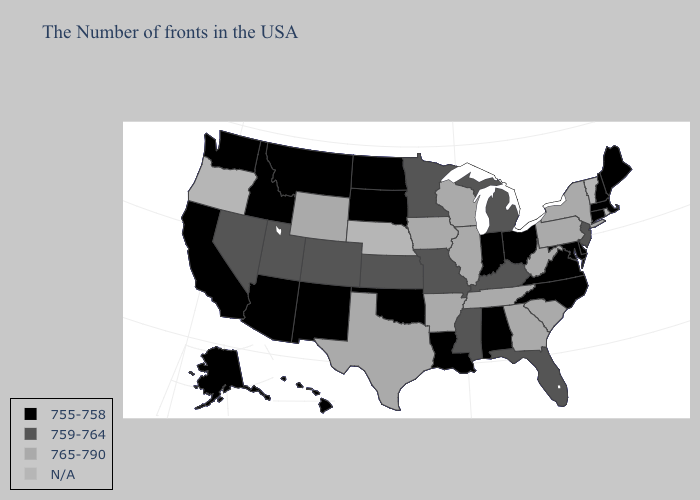Name the states that have a value in the range 759-764?
Answer briefly. New Jersey, Florida, Michigan, Kentucky, Mississippi, Missouri, Minnesota, Kansas, Colorado, Utah, Nevada. What is the highest value in the Northeast ?
Concise answer only. 765-790. Name the states that have a value in the range 765-790?
Write a very short answer. New York, Pennsylvania, South Carolina, West Virginia, Georgia, Tennessee, Wisconsin, Illinois, Arkansas, Iowa, Texas, Wyoming. Name the states that have a value in the range N/A?
Keep it brief. Rhode Island, Vermont, Nebraska, Oregon. What is the lowest value in the USA?
Quick response, please. 755-758. What is the value of North Dakota?
Be succinct. 755-758. What is the highest value in the USA?
Keep it brief. 765-790. What is the value of Oklahoma?
Be succinct. 755-758. Name the states that have a value in the range 755-758?
Answer briefly. Maine, Massachusetts, New Hampshire, Connecticut, Delaware, Maryland, Virginia, North Carolina, Ohio, Indiana, Alabama, Louisiana, Oklahoma, South Dakota, North Dakota, New Mexico, Montana, Arizona, Idaho, California, Washington, Alaska, Hawaii. Name the states that have a value in the range 755-758?
Write a very short answer. Maine, Massachusetts, New Hampshire, Connecticut, Delaware, Maryland, Virginia, North Carolina, Ohio, Indiana, Alabama, Louisiana, Oklahoma, South Dakota, North Dakota, New Mexico, Montana, Arizona, Idaho, California, Washington, Alaska, Hawaii. Among the states that border Washington , which have the highest value?
Keep it brief. Idaho. Among the states that border Utah , which have the lowest value?
Answer briefly. New Mexico, Arizona, Idaho. Name the states that have a value in the range 755-758?
Write a very short answer. Maine, Massachusetts, New Hampshire, Connecticut, Delaware, Maryland, Virginia, North Carolina, Ohio, Indiana, Alabama, Louisiana, Oklahoma, South Dakota, North Dakota, New Mexico, Montana, Arizona, Idaho, California, Washington, Alaska, Hawaii. Name the states that have a value in the range N/A?
Write a very short answer. Rhode Island, Vermont, Nebraska, Oregon. 